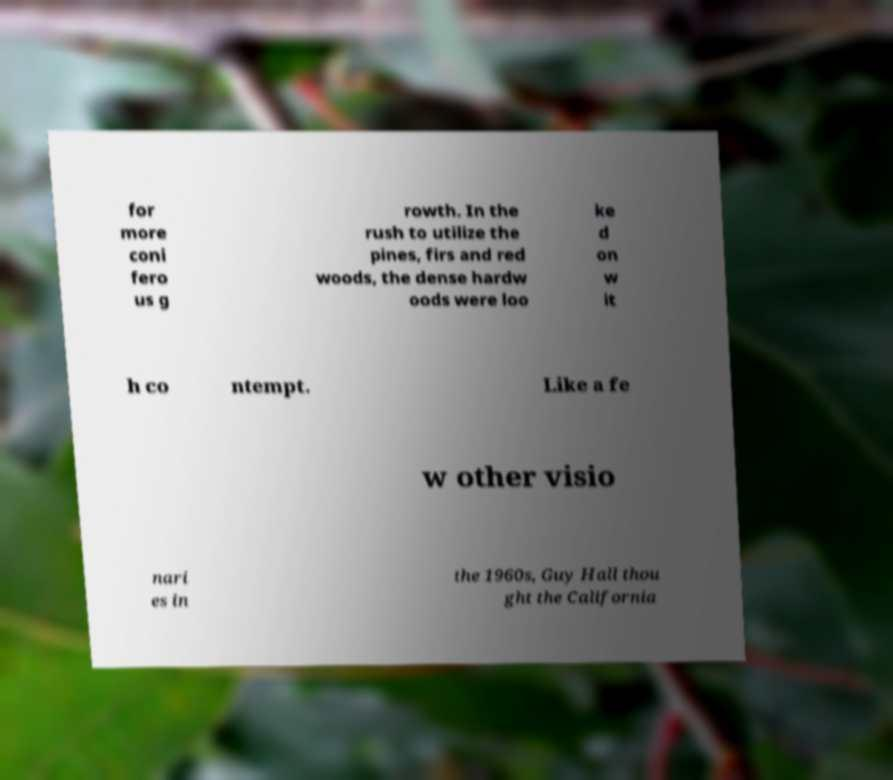Could you extract and type out the text from this image? for more coni fero us g rowth. In the rush to utilize the pines, firs and red woods, the dense hardw oods were loo ke d on w it h co ntempt. Like a fe w other visio nari es in the 1960s, Guy Hall thou ght the California 